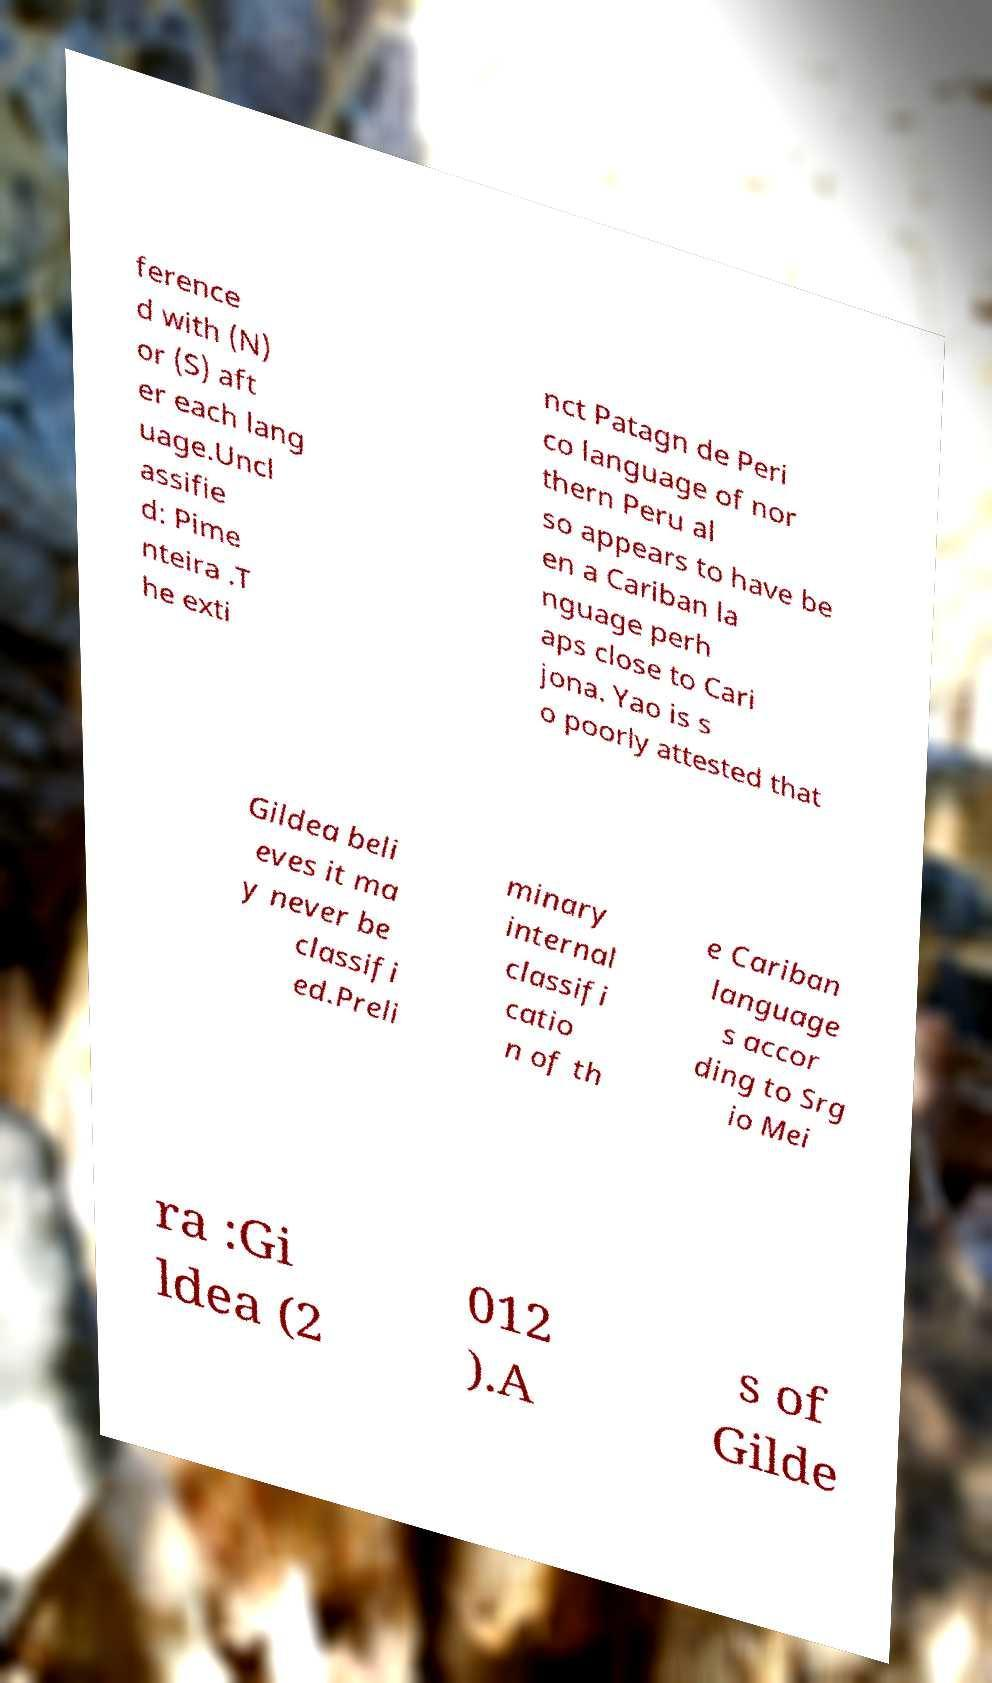Could you assist in decoding the text presented in this image and type it out clearly? ference d with (N) or (S) aft er each lang uage.Uncl assifie d: Pime nteira .T he exti nct Patagn de Peri co language of nor thern Peru al so appears to have be en a Cariban la nguage perh aps close to Cari jona. Yao is s o poorly attested that Gildea beli eves it ma y never be classifi ed.Preli minary internal classifi catio n of th e Cariban language s accor ding to Srg io Mei ra :Gi ldea (2 012 ).A s of Gilde 